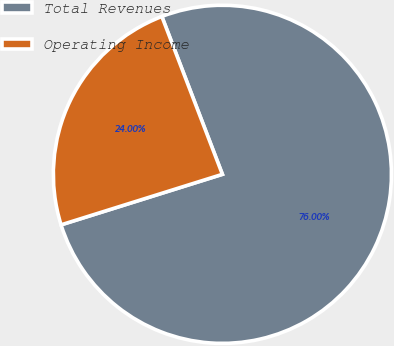<chart> <loc_0><loc_0><loc_500><loc_500><pie_chart><fcel>Total Revenues<fcel>Operating Income<nl><fcel>76.0%<fcel>24.0%<nl></chart> 